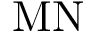<formula> <loc_0><loc_0><loc_500><loc_500>M N</formula> 